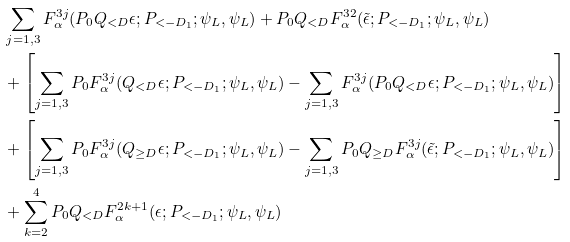<formula> <loc_0><loc_0><loc_500><loc_500>& \sum _ { j = 1 , 3 } F _ { \alpha } ^ { 3 j } ( P _ { 0 } Q _ { < D } \epsilon ; P _ { < - D _ { 1 } } ; \psi _ { L } , \psi _ { L } ) + P _ { 0 } Q _ { < D } F _ { \alpha } ^ { 3 2 } ( \tilde { \epsilon } ; P _ { < - D _ { 1 } } ; \psi _ { L } , \psi _ { L } ) \\ & + \left [ \sum _ { j = 1 , 3 } P _ { 0 } F _ { \alpha } ^ { 3 j } ( Q _ { < D } \epsilon ; P _ { < - D _ { 1 } } ; \psi _ { L } , \psi _ { L } ) - \sum _ { j = 1 , 3 } F _ { \alpha } ^ { 3 j } ( P _ { 0 } Q _ { < D } \epsilon ; P _ { < - D _ { 1 } } ; \psi _ { L } , \psi _ { L } ) \right ] \\ & + \left [ \sum _ { j = 1 , 3 } P _ { 0 } F _ { \alpha } ^ { 3 j } ( Q _ { \geq D } \epsilon ; P _ { < - D _ { 1 } } ; \psi _ { L } , \psi _ { L } ) - \sum _ { j = 1 , 3 } P _ { 0 } Q _ { \geq D } F _ { \alpha } ^ { 3 j } ( \tilde { \epsilon } ; P _ { < - D _ { 1 } } ; \psi _ { L } , \psi _ { L } ) \right ] \\ & + \sum _ { k = 2 } ^ { 4 } P _ { 0 } Q _ { < D } F _ { \alpha } ^ { 2 k + 1 } ( \epsilon ; P _ { < - D _ { 1 } } ; \psi _ { L } , \psi _ { L } )</formula> 